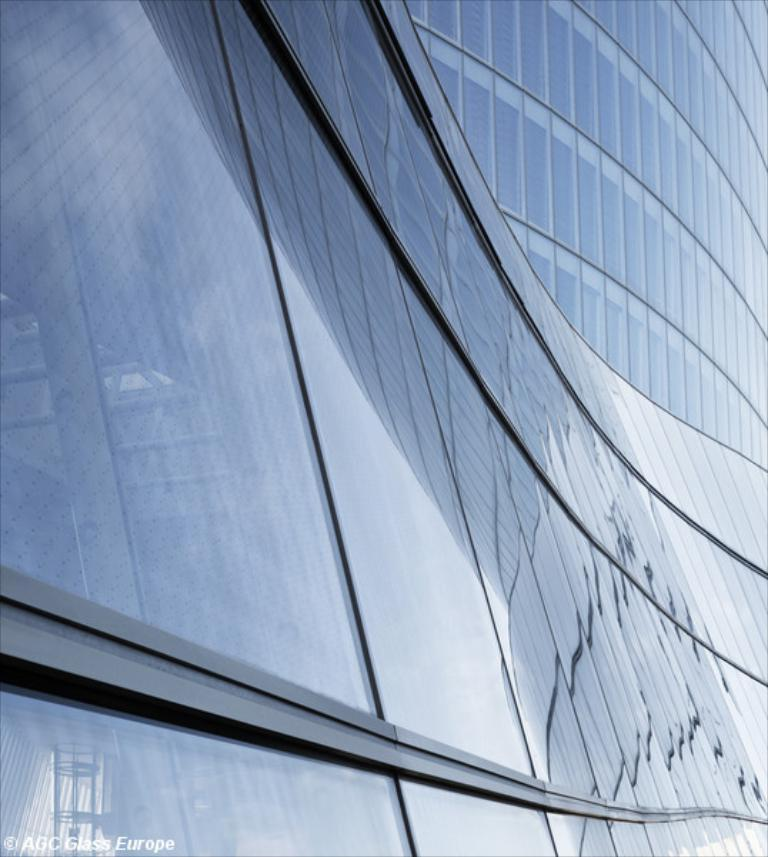What type of building is depicted in the image? There is a glass building in the image. Can you describe any additional features or characteristics of the building? Unfortunately, the provided facts do not mention any specific features or characteristics of the building. Is there any text or marking visible in the image? Yes, there is a watermark on the bottom left side of the image. What type of frog can be seen jumping in the image? There is no frog present in the image. What achievements are being celebrated by the achiever in the image? There is no achiever or any indication of achievements being celebrated in the image. What type of breakfast is being served in the image? There is no breakfast or any food items visible in the image. 